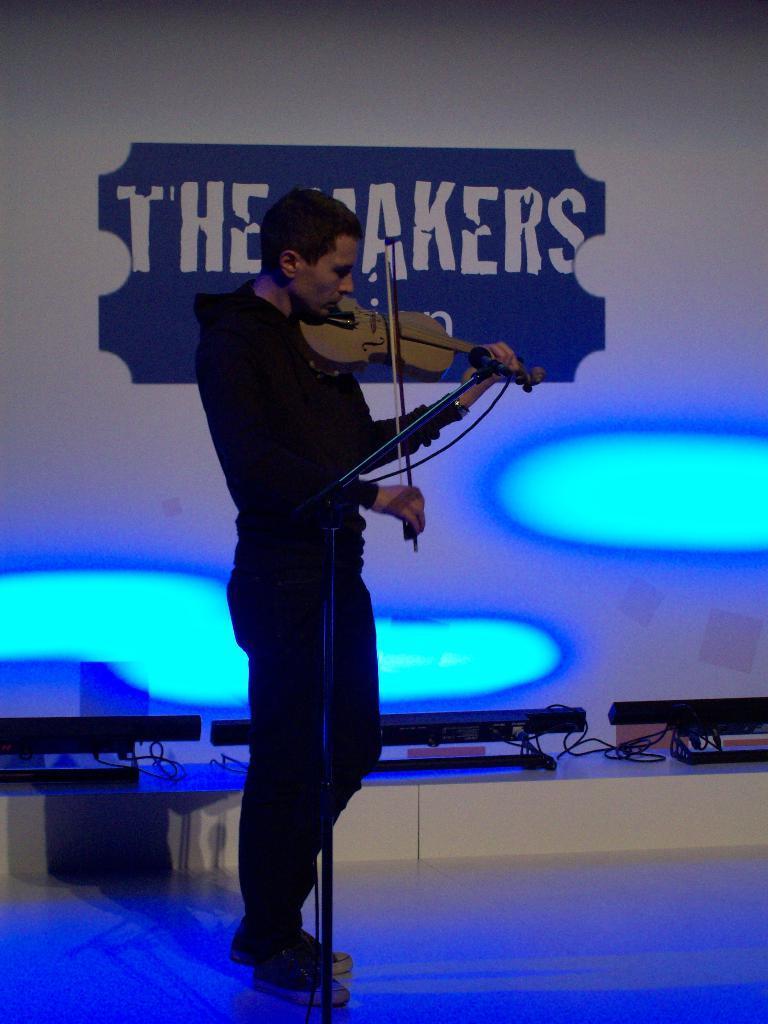Please provide a concise description of this image. In this image the person is standing and holding the violin. At the back side there is a banner and the quotation written"The Markers". The person is standing on the stage. There is a mic and a stand. 